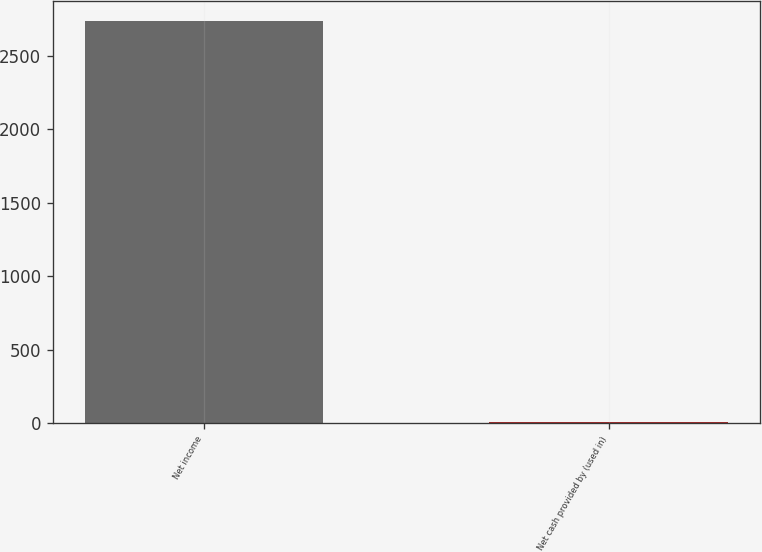Convert chart. <chart><loc_0><loc_0><loc_500><loc_500><bar_chart><fcel>Net income<fcel>Net cash provided by (used in)<nl><fcel>2736<fcel>7<nl></chart> 